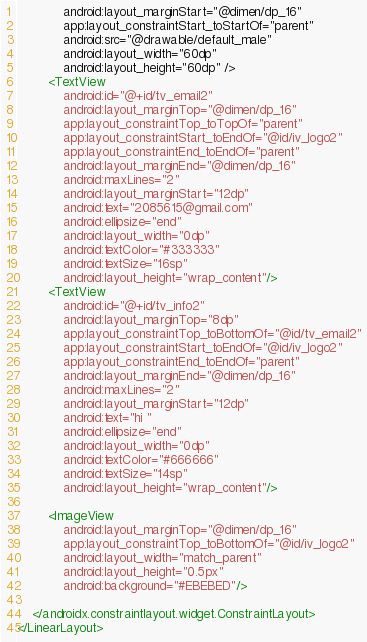<code> <loc_0><loc_0><loc_500><loc_500><_XML_>            android:layout_marginStart="@dimen/dp_16"
            app:layout_constraintStart_toStartOf="parent"
            android:src="@drawable/default_male"
            android:layout_width="60dp"
            android:layout_height="60dp" />
        <TextView
            android:id="@+id/tv_email2"
            android:layout_marginTop="@dimen/dp_16"
            app:layout_constraintTop_toTopOf="parent"
            app:layout_constraintStart_toEndOf="@id/iv_logo2"
            app:layout_constraintEnd_toEndOf="parent"
            android:layout_marginEnd="@dimen/dp_16"
            android:maxLines="2"
            android:layout_marginStart="12dp"
            android:text="2085615@gmail.com"
            android:ellipsize="end"
            android:layout_width="0dp"
            android:textColor="#333333"
            android:textSize="16sp"
            android:layout_height="wrap_content"/>
        <TextView
            android:id="@+id/tv_info2"
            android:layout_marginTop="8dp"
            app:layout_constraintTop_toBottomOf="@id/tv_email2"
            app:layout_constraintStart_toEndOf="@id/iv_logo2"
            app:layout_constraintEnd_toEndOf="parent"
            android:layout_marginEnd="@dimen/dp_16"
            android:maxLines="2"
            android:layout_marginStart="12dp"
            android:text="hi "
            android:ellipsize="end"
            android:layout_width="0dp"
            android:textColor="#666666"
            android:textSize="14sp"
            android:layout_height="wrap_content"/>

        <ImageView
            android:layout_marginTop="@dimen/dp_16"
            app:layout_constraintTop_toBottomOf="@id/iv_logo2"
            android:layout_width="match_parent"
            android:layout_height="0.5px"
            android:background="#EBEBED"/>

    </androidx.constraintlayout.widget.ConstraintLayout>
</LinearLayout>
</code> 